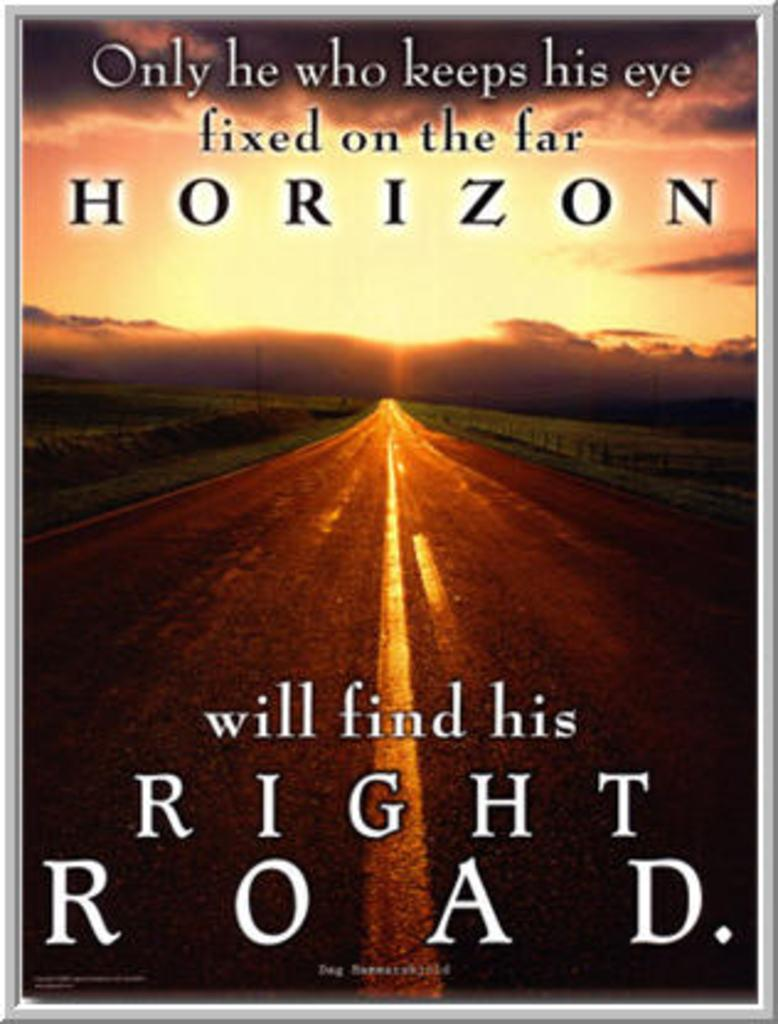<image>
Describe the image concisely. A book cover has the word horizon in large print towards the top. 